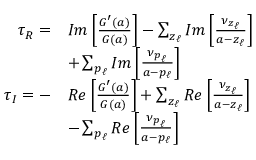<formula> <loc_0><loc_0><loc_500><loc_500>\begin{array} { r } { \begin{array} { r l } { \tau _ { R } = } & { I m \left [ \frac { G ^ { \prime } ( a ) } { G ( a ) } \right ] - \sum _ { z _ { \ell } } I m \left [ \frac { \nu _ { z _ { \ell } } } { a - z _ { \ell } } \right ] } \\ & { + \sum _ { p _ { \ell } } I m \left [ \frac { \nu _ { p _ { \ell } } } { a - p _ { \ell } } \right ] } \\ { \tau _ { I } = - } & { R e \left [ \frac { G ^ { \prime } ( a ) } { G ( a ) } \right ] + \sum _ { z _ { \ell } } R e \left [ \frac { \nu _ { z _ { \ell } } } { a - z _ { \ell } } \right ] } \\ & { - \sum _ { p _ { \ell } } R e \left [ \frac { \nu _ { p _ { \ell } } } { a - p _ { \ell } } \right ] } \end{array} } \end{array}</formula> 